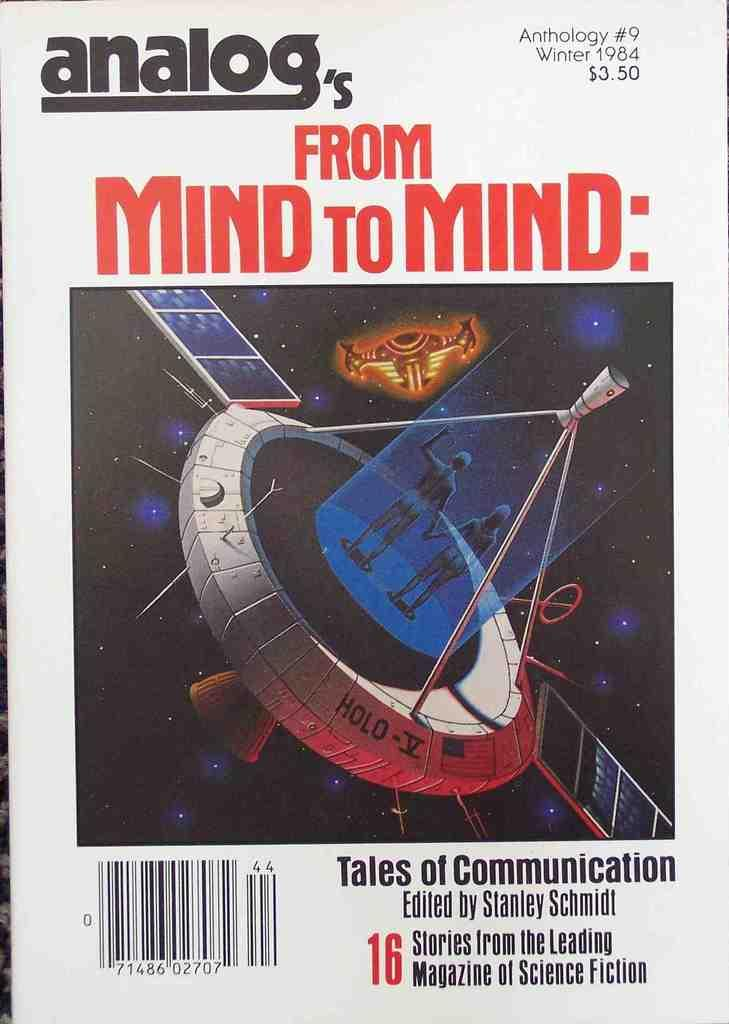<image>
Share a concise interpretation of the image provided. Book cover titled "From Mind to Mind" by Stanley Schmidt. 